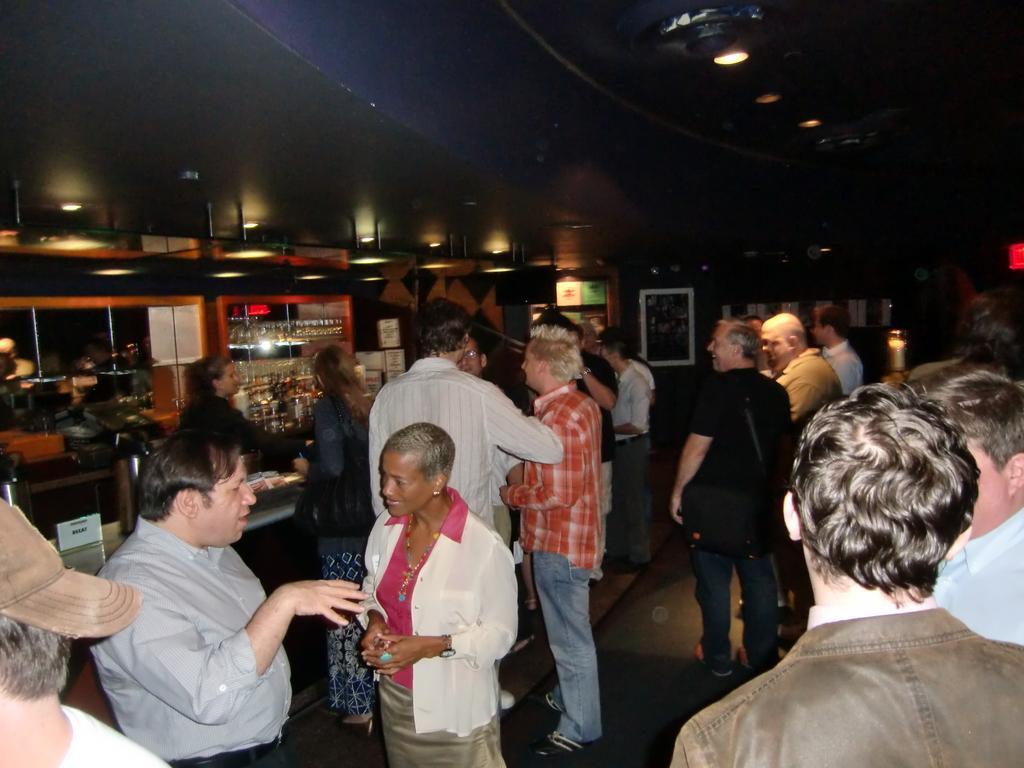How would you summarize this image in a sentence or two? People are standing. There are bottles in the shelves. There are lights. There are photo frames at the back. 